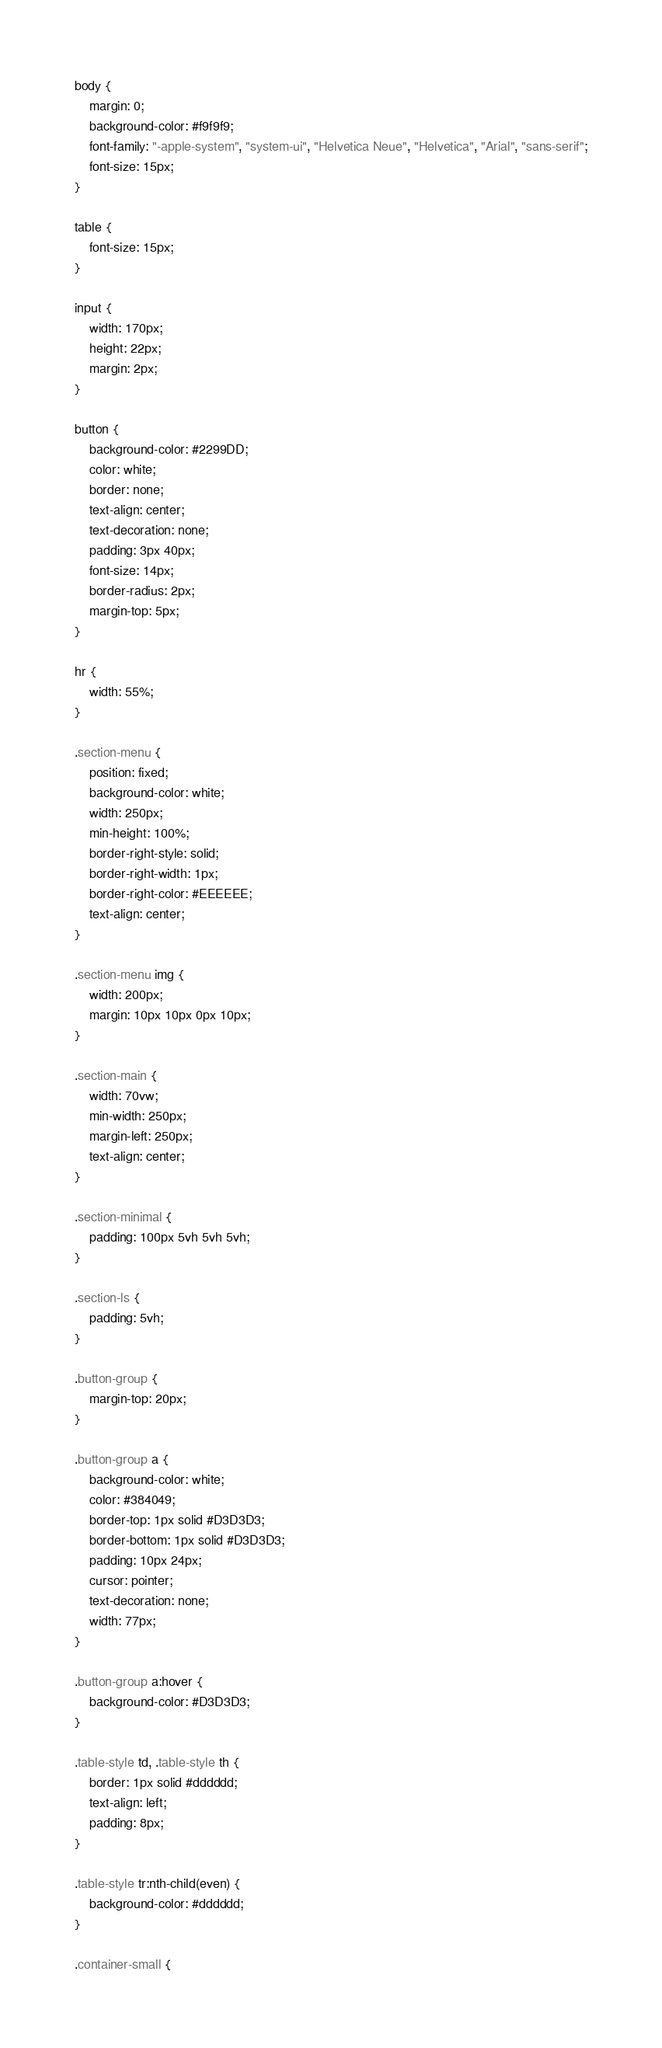<code> <loc_0><loc_0><loc_500><loc_500><_CSS_>body {
    margin: 0;
    background-color: #f9f9f9;
    font-family: "-apple-system", "system-ui", "Helvetica Neue", "Helvetica", "Arial", "sans-serif";
    font-size: 15px;
}

table {
    font-size: 15px;
}

input {
    width: 170px;
    height: 22px;
    margin: 2px;
}

button {
    background-color: #2299DD;
    color: white;
    border: none;
    text-align: center;
    text-decoration: none;
    padding: 3px 40px;
    font-size: 14px;
    border-radius: 2px;
    margin-top: 5px;
}

hr {
    width: 55%;
}

.section-menu {
    position: fixed;
    background-color: white;
    width: 250px;
    min-height: 100%;
    border-right-style: solid;
    border-right-width: 1px;
    border-right-color: #EEEEEE;
    text-align: center;
}

.section-menu img {
    width: 200px;
    margin: 10px 10px 0px 10px;
}

.section-main {
    width: 70vw;
    min-width: 250px;
    margin-left: 250px;
    text-align: center;
}

.section-minimal {
    padding: 100px 5vh 5vh 5vh;
}

.section-ls {
    padding: 5vh;
}

.button-group {
    margin-top: 20px;
}

.button-group a {
    background-color: white;
    color: #384049;
    border-top: 1px solid #D3D3D3;
    border-bottom: 1px solid #D3D3D3;
    padding: 10px 24px;
    cursor: pointer;
    text-decoration: none;
    width: 77px;
}

.button-group a:hover {
    background-color: #D3D3D3;
}

.table-style td, .table-style th {
    border: 1px solid #dddddd;
    text-align: left;
    padding: 8px;
}

.table-style tr:nth-child(even) {
    background-color: #dddddd;
}

.container-small {</code> 